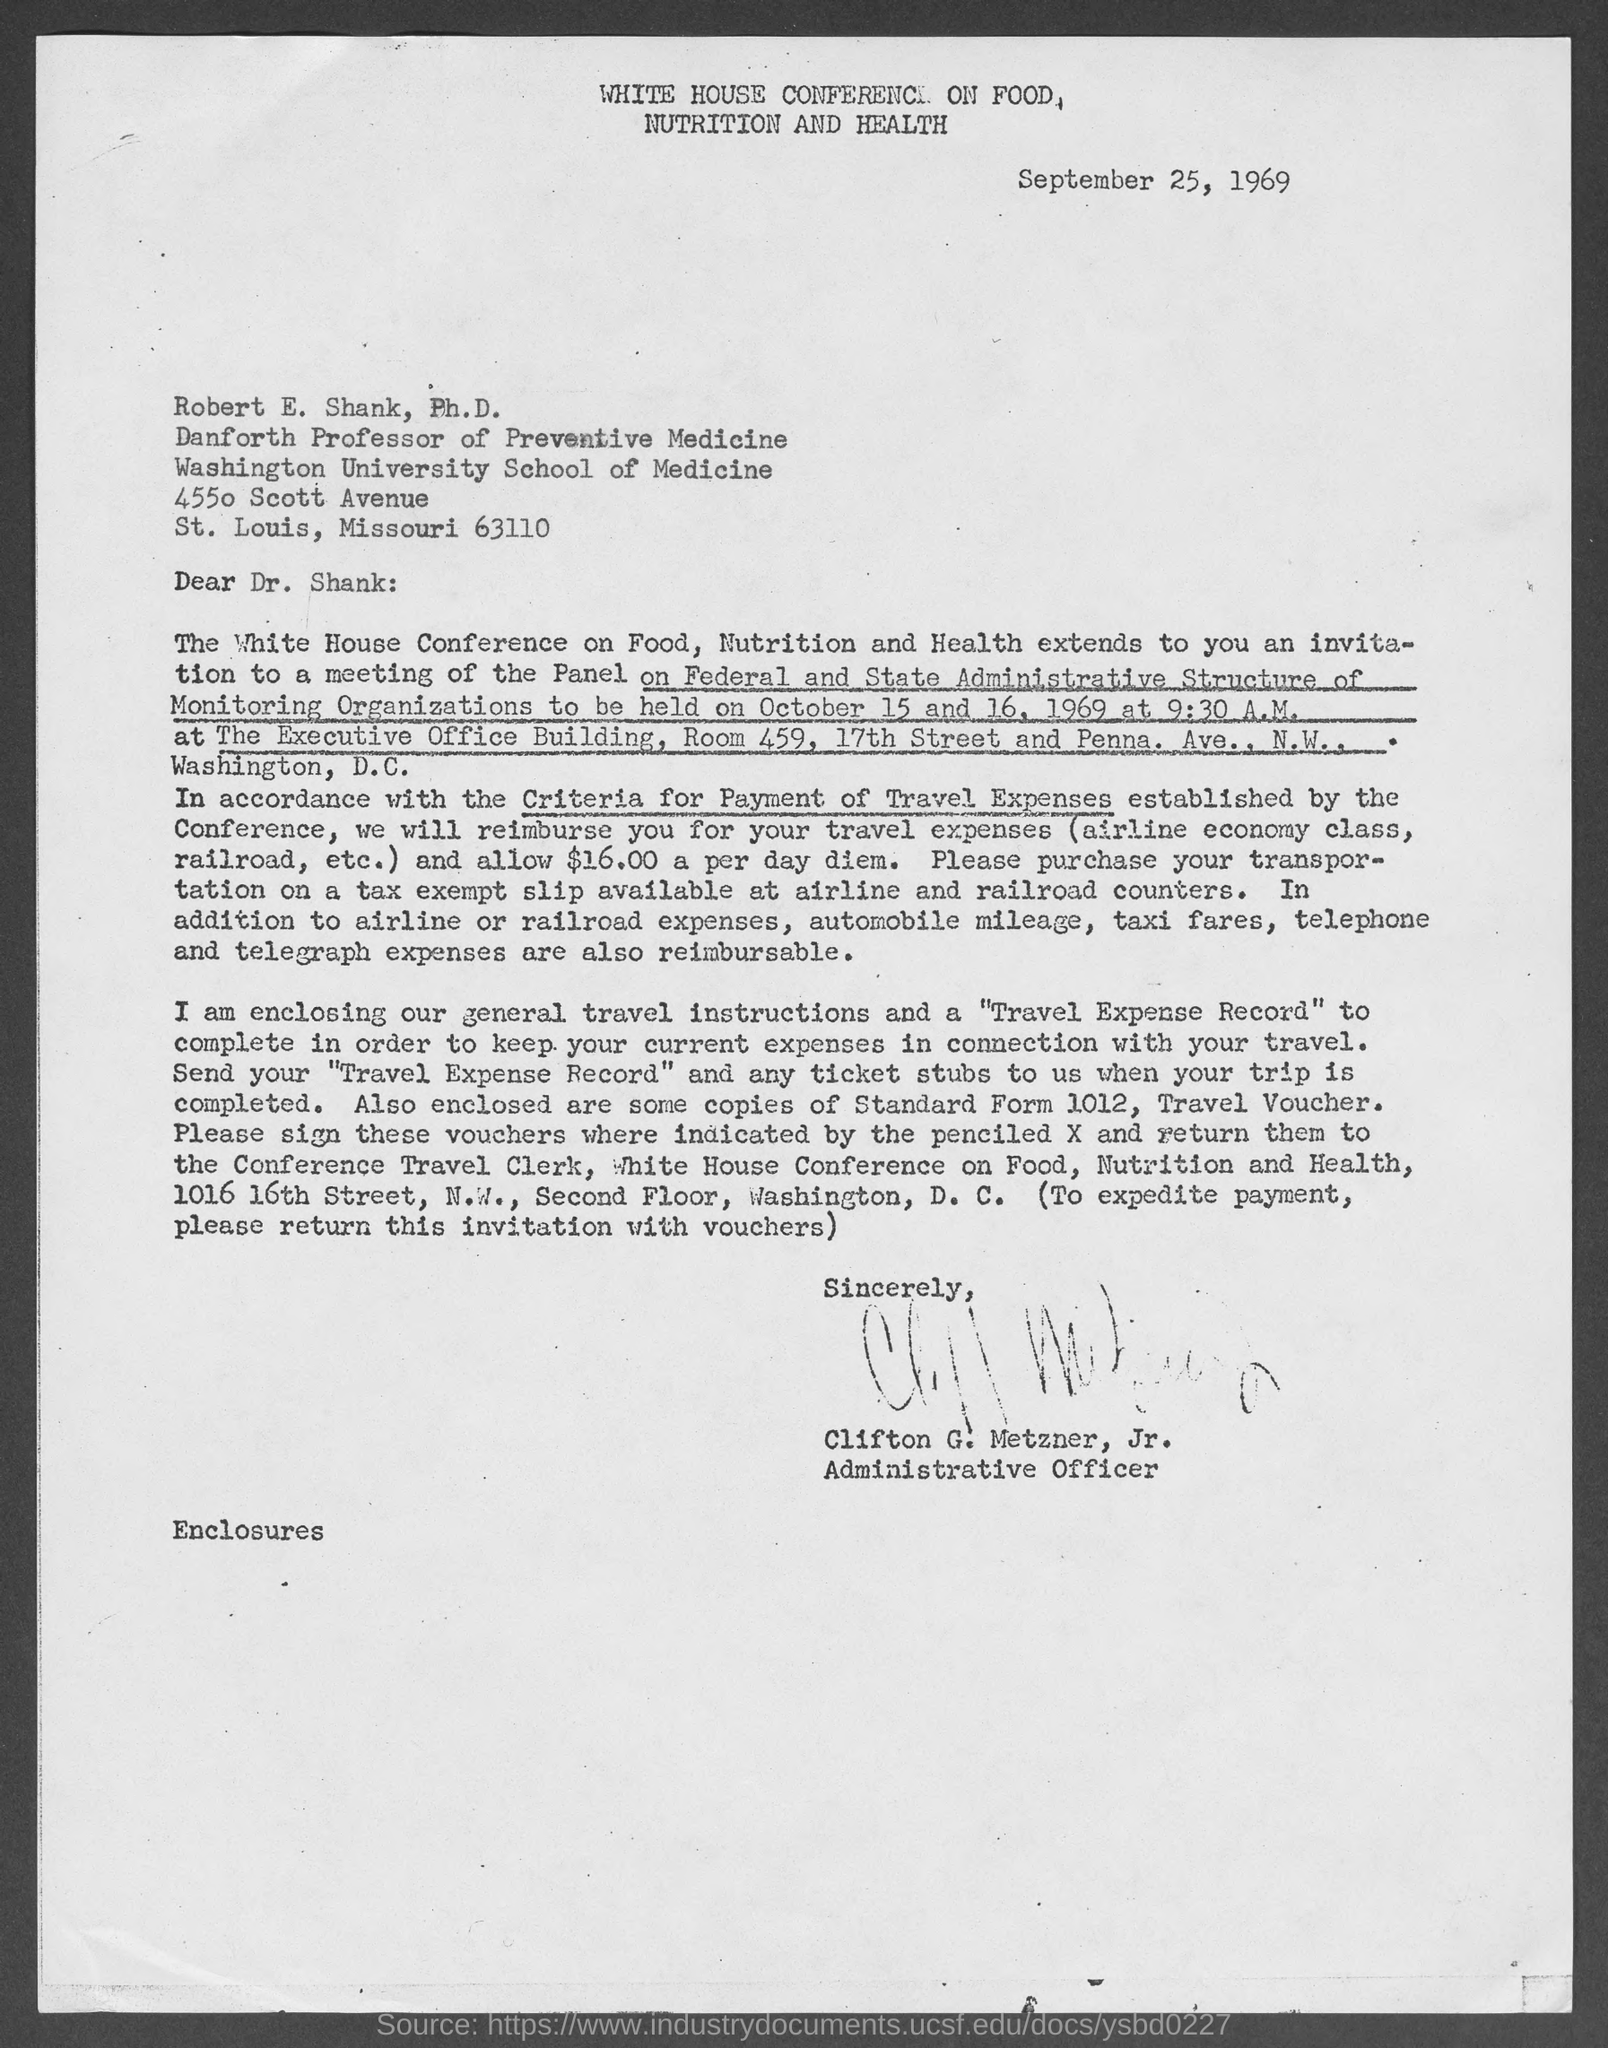When is the document dated?
Your response must be concise. September 25, 1969. What is written on the top of the page?
Provide a succinct answer. WHITE HOUSE CONFERENCE ON FOOD, NUTRITION AND HEALTH. From whom is the letter?
Ensure brevity in your answer.  Clifton G. Metzner, Jr. What is Clifton's designation?
Your answer should be compact. Administrative Officer. What is the meeting of the Panel on?
Make the answer very short. Federal and State Administrative Structure of Monitoring Organizations. On which date is the meeting going to be held?
Make the answer very short. October 15 and 16, 1969. In accordance with which criteria will Dr. Shank be reimbursed?
Keep it short and to the point. Criteria for Payment of Travel expenses. 